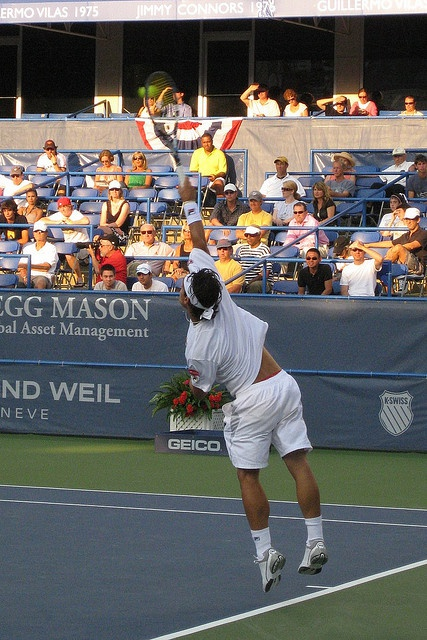Describe the objects in this image and their specific colors. I can see people in darkgray, gray, and black tones, people in darkgray, ivory, black, maroon, and orange tones, tennis racket in darkgray, black, gray, and olive tones, people in darkgray, orange, maroon, and black tones, and people in darkgray, lightgray, tan, and brown tones in this image. 